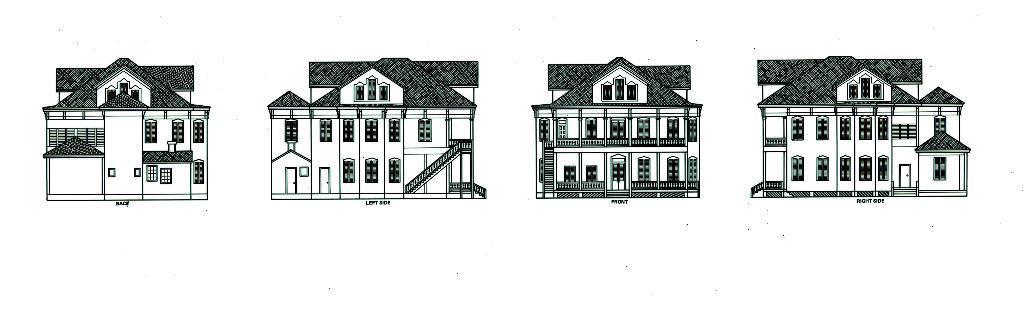Can you describe this image briefly? In this picture, we see an art or sketch of four buildings. At the bottom of each building, we see some text written. In the background, it is white in color. 